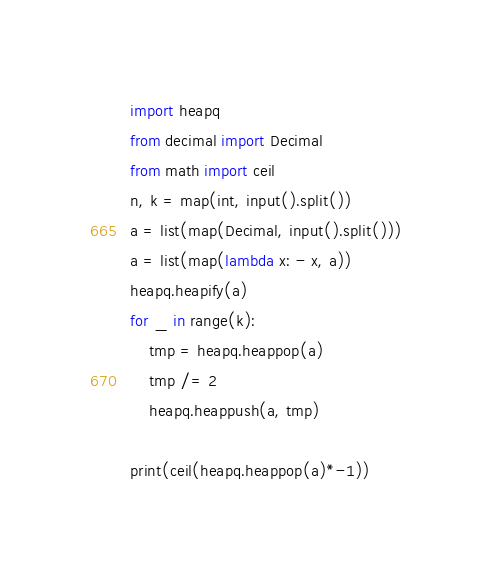<code> <loc_0><loc_0><loc_500><loc_500><_Python_>import heapq
from decimal import Decimal
from math import ceil
n, k = map(int, input().split())
a = list(map(Decimal, input().split()))
a = list(map(lambda x: - x, a))
heapq.heapify(a)
for _ in range(k):
    tmp = heapq.heappop(a)
    tmp /= 2
    heapq.heappush(a, tmp)

print(ceil(heapq.heappop(a)*-1))
</code> 